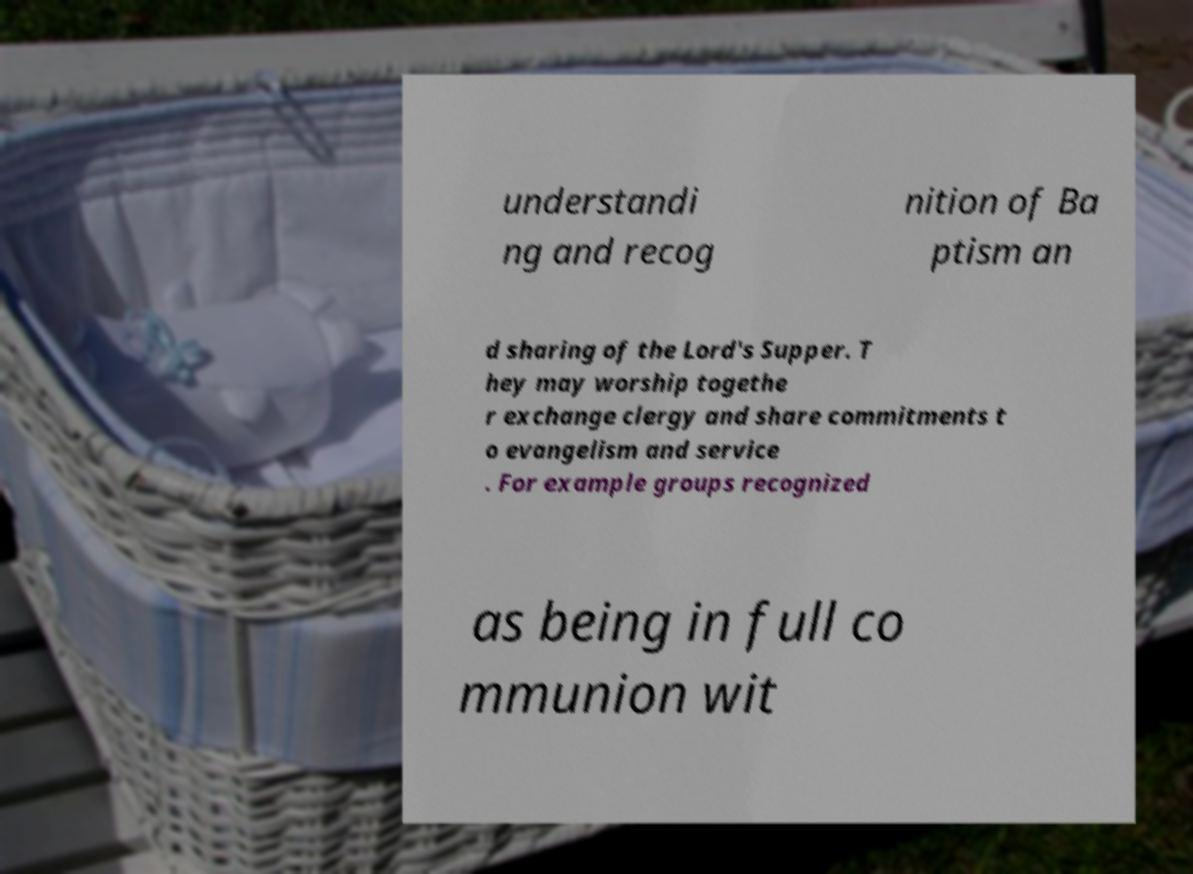Please identify and transcribe the text found in this image. understandi ng and recog nition of Ba ptism an d sharing of the Lord's Supper. T hey may worship togethe r exchange clergy and share commitments t o evangelism and service . For example groups recognized as being in full co mmunion wit 